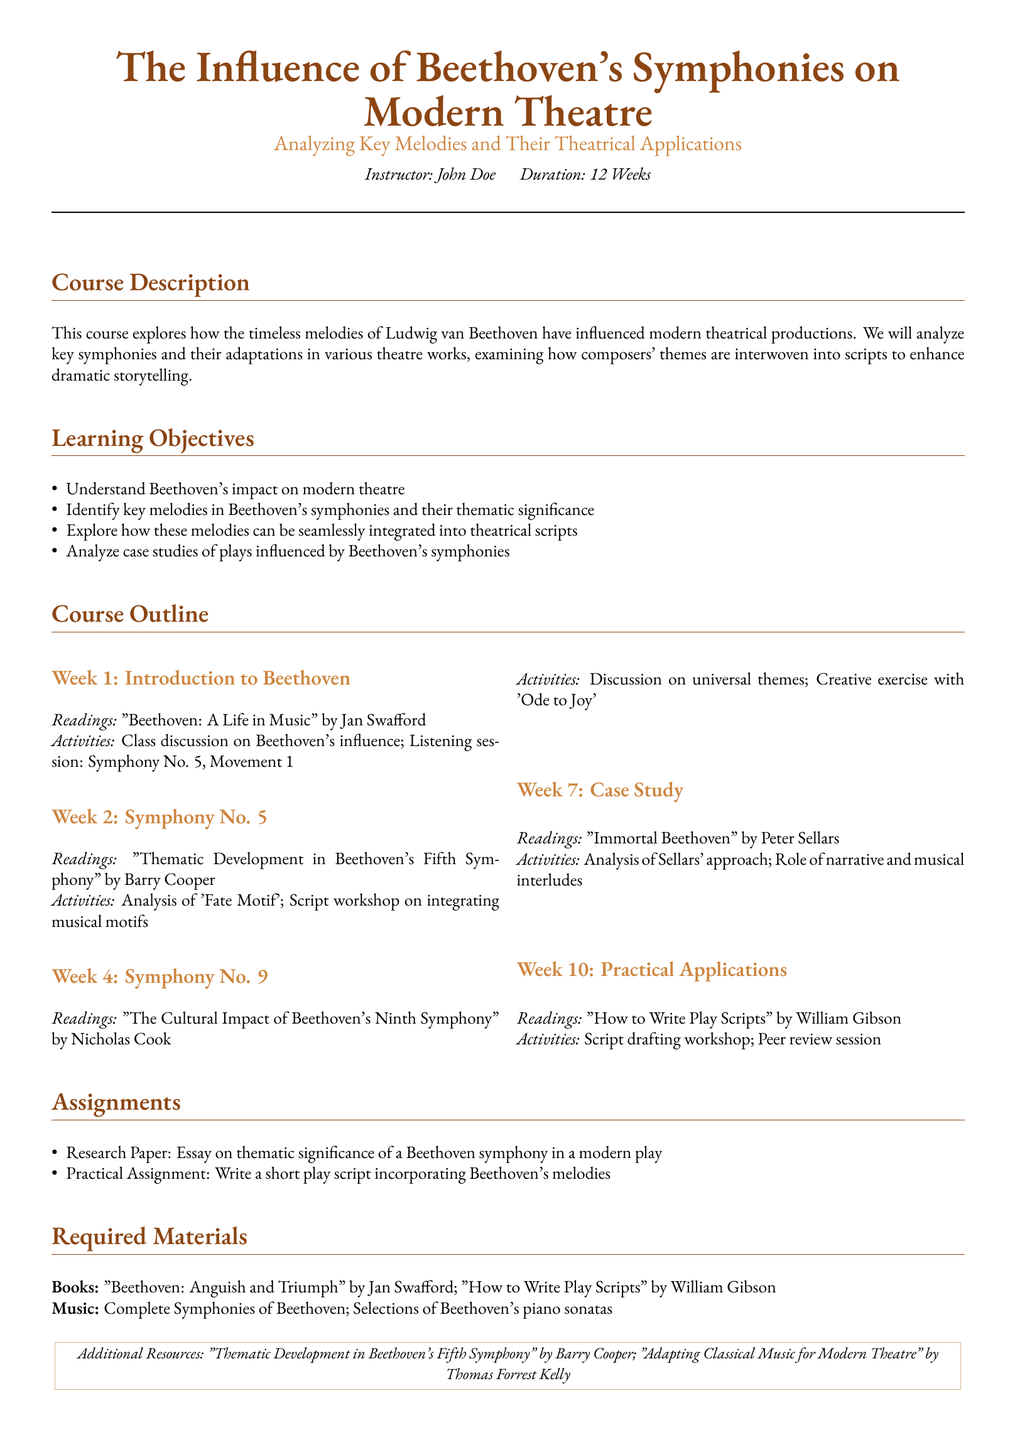What is the duration of the course? The duration of the course is specified at the beginning of the document.
Answer: 12 Weeks Who is the instructor of the course? The name of the instructor is listed in the course title section.
Answer: John Doe What is one of the required books for the course? The required materials section specifies books needed for the course.
Answer: Beethoven: Anguish and Triumph In which week is Symphony No. 9 discussed? The course outline details the topics covered each week.
Answer: Week 4 What is one assignment for the course? The assignments section lists the tasks assigned for the course.
Answer: Research Paper What is the key theme analyzed in Week 2? The activities section for Week 2 mentions specific themes being analyzed.
Answer: 'Fate Motif' What musical piece is explored in Week 10? The activities listed for Week 10 highlight practical applications of music.
Answer: Beethoven's melodies Which reading covers Beethoven's cultural impact? The course outline lists readings associated with each week and their focus.
Answer: The Cultural Impact of Beethoven's Ninth Symphony What type of exercise is included for 'Ode to Joy'? The activities for Week 4 describe the type of exercise related to the symphony.
Answer: Creative exercise 